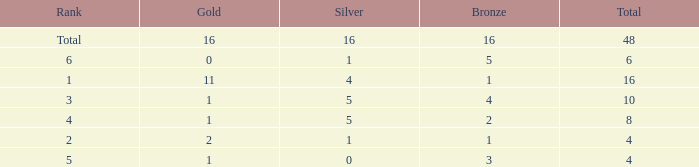What is the total gold that has bronze less than 2, a silver of 1 and total more than 4? None. 